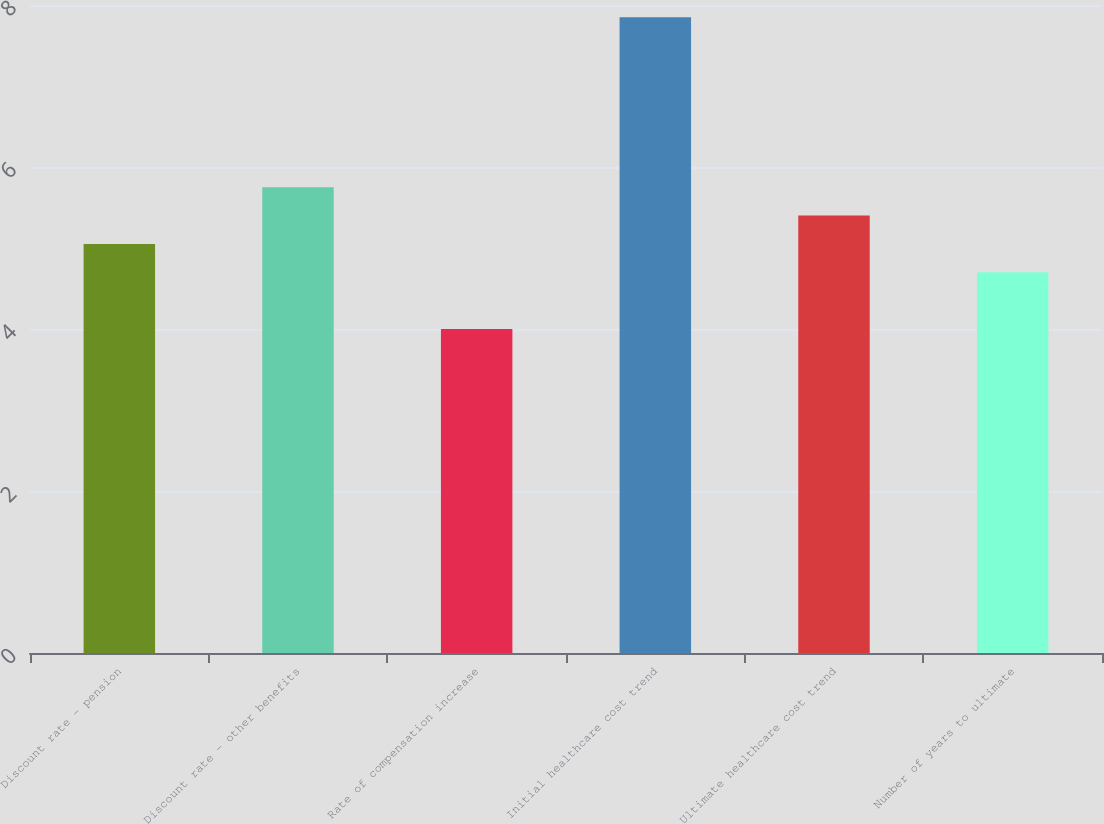Convert chart to OTSL. <chart><loc_0><loc_0><loc_500><loc_500><bar_chart><fcel>Discount rate - pension<fcel>Discount rate - other benefits<fcel>Rate of compensation increase<fcel>Initial healthcare cost trend<fcel>Ultimate healthcare cost trend<fcel>Number of years to ultimate<nl><fcel>5.05<fcel>5.75<fcel>4<fcel>7.85<fcel>5.4<fcel>4.7<nl></chart> 